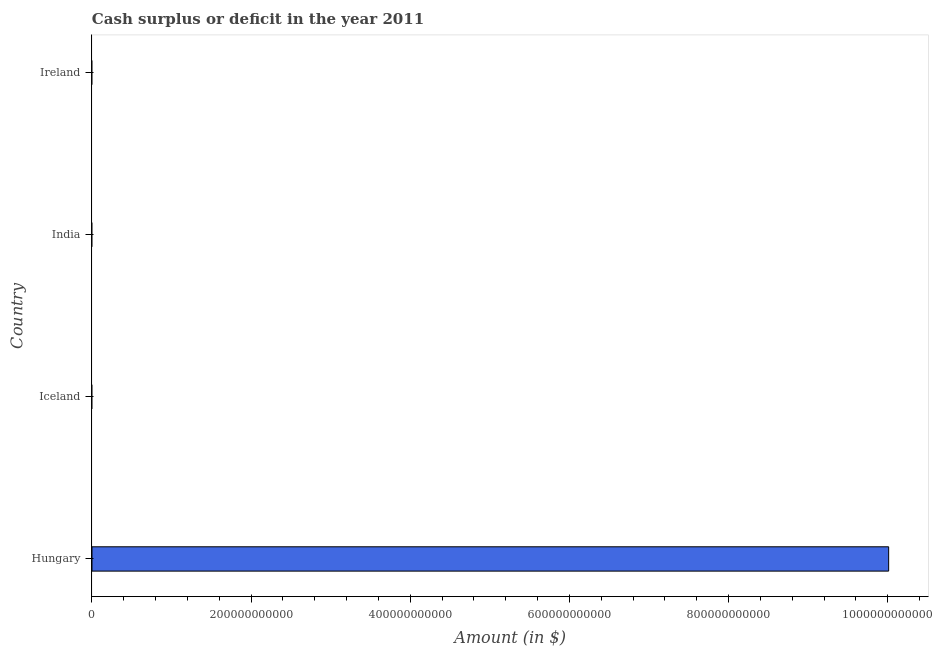What is the title of the graph?
Make the answer very short. Cash surplus or deficit in the year 2011. What is the label or title of the X-axis?
Provide a succinct answer. Amount (in $). What is the label or title of the Y-axis?
Offer a very short reply. Country. What is the cash surplus or deficit in Hungary?
Offer a very short reply. 1.00e+12. Across all countries, what is the maximum cash surplus or deficit?
Give a very brief answer. 1.00e+12. Across all countries, what is the minimum cash surplus or deficit?
Your answer should be very brief. 0. In which country was the cash surplus or deficit maximum?
Provide a succinct answer. Hungary. What is the sum of the cash surplus or deficit?
Provide a succinct answer. 1.00e+12. What is the average cash surplus or deficit per country?
Offer a terse response. 2.50e+11. What is the median cash surplus or deficit?
Give a very brief answer. 0. In how many countries, is the cash surplus or deficit greater than 80000000000 $?
Give a very brief answer. 1. What is the difference between the highest and the lowest cash surplus or deficit?
Ensure brevity in your answer.  1.00e+12. How many bars are there?
Provide a short and direct response. 1. Are all the bars in the graph horizontal?
Offer a terse response. Yes. How many countries are there in the graph?
Offer a very short reply. 4. What is the difference between two consecutive major ticks on the X-axis?
Keep it short and to the point. 2.00e+11. What is the Amount (in $) of Hungary?
Keep it short and to the point. 1.00e+12. What is the Amount (in $) of Iceland?
Give a very brief answer. 0. What is the Amount (in $) of Ireland?
Give a very brief answer. 0. 